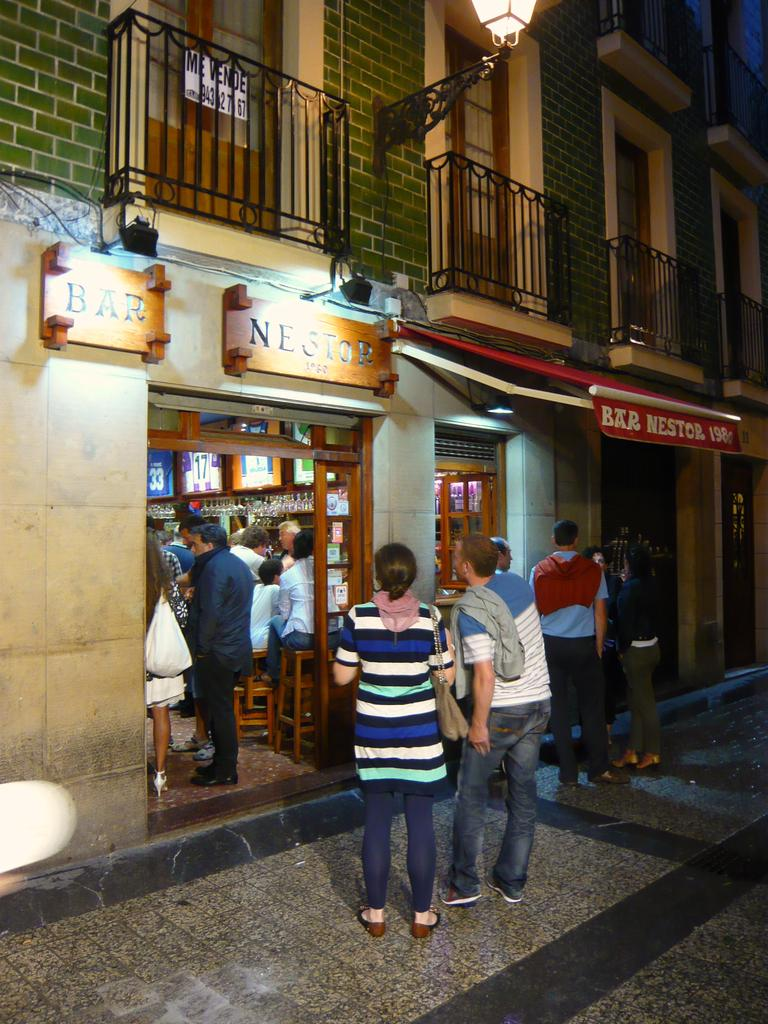What is the primary location of the people in the image? The people are on the ground in the image. What type of structure can be seen in the image? There is a building in the image. What are the name boards used for in the image? The name boards are used for identification or direction in the image. Can you describe any objects visible in the image? There are objects visible in the image, but their specific nature is not mentioned in the provided facts. What type of arch can be seen in the image? There is no arch present in the image. What kind of humor is being displayed by the people in the image? The provided facts do not mention any humor or comedic elements in the image. 